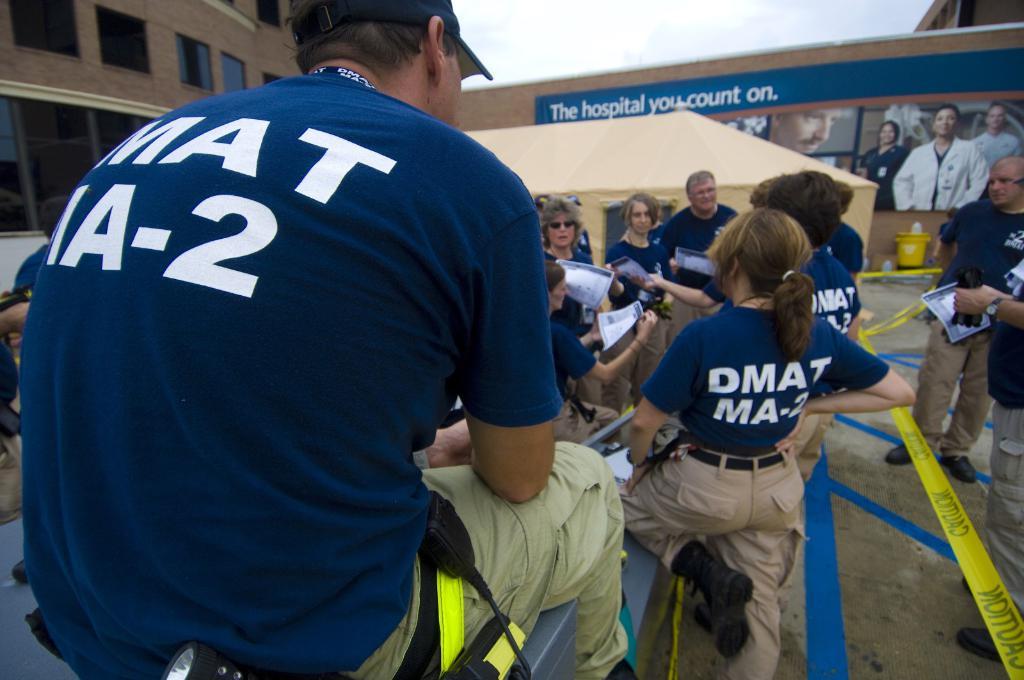What is the slogan for this hospital?
Your response must be concise. The hospital you count on. What number is on the mans back?
Ensure brevity in your answer.  2. 